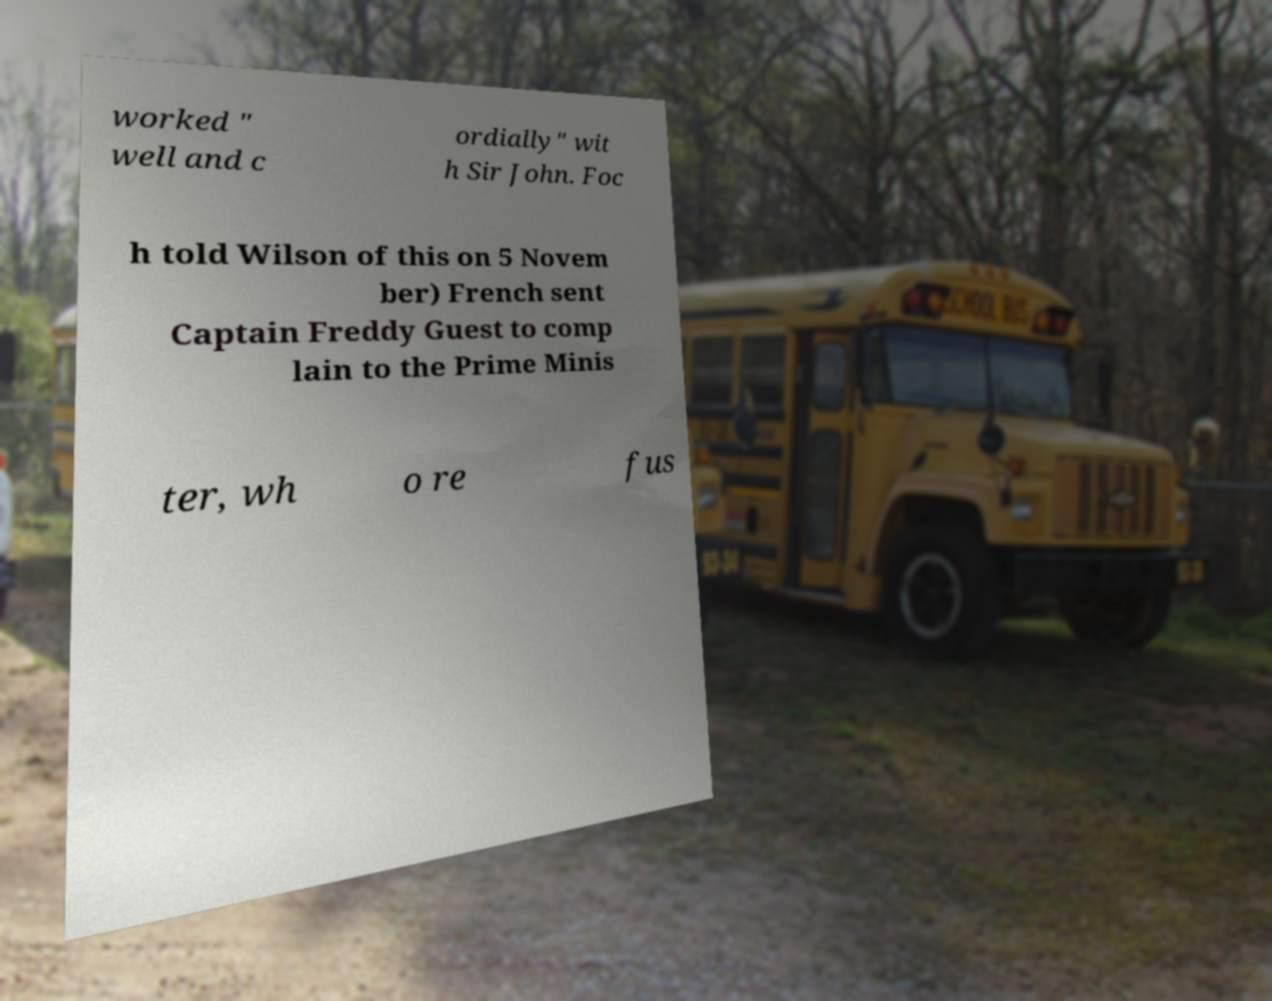Can you accurately transcribe the text from the provided image for me? worked " well and c ordially" wit h Sir John. Foc h told Wilson of this on 5 Novem ber) French sent Captain Freddy Guest to comp lain to the Prime Minis ter, wh o re fus 